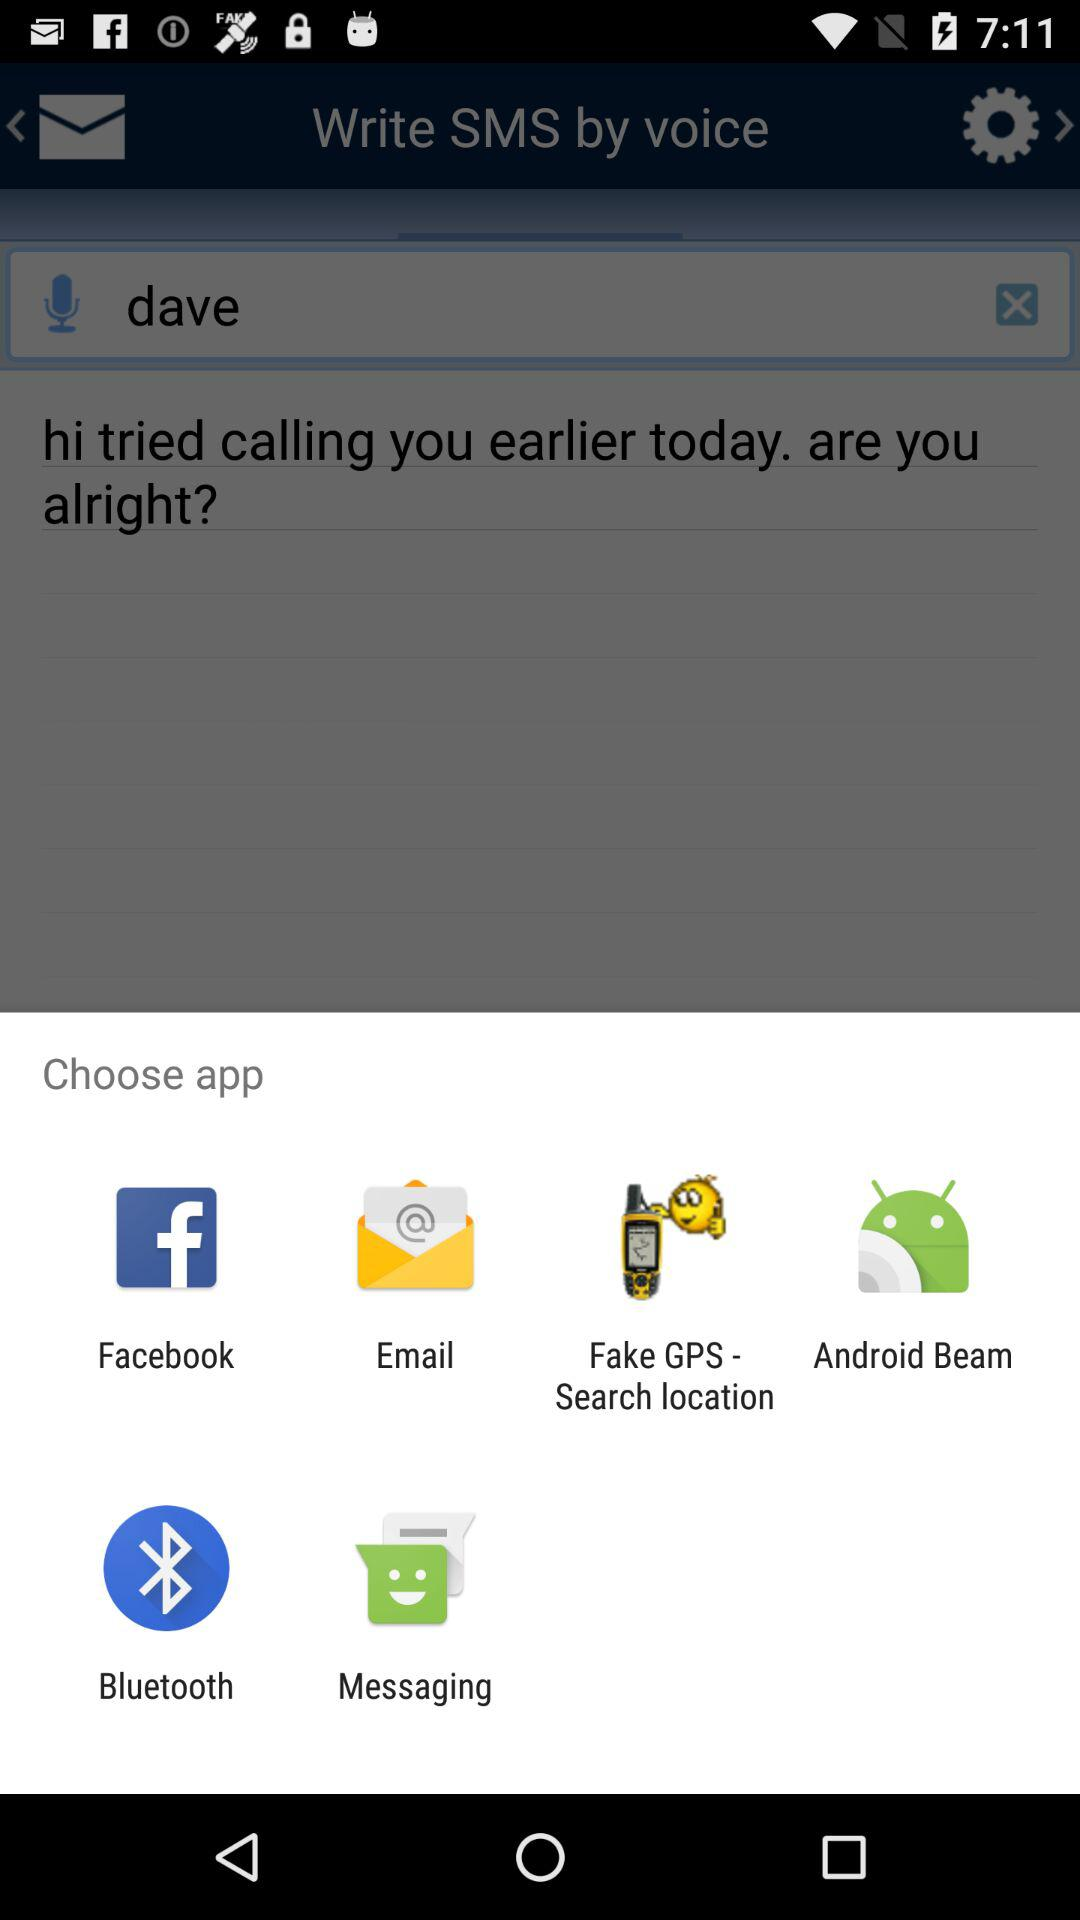What app options are given for choosing? The app options are Facebook, Email, Fake GPS - Search location, Android Beam, Bluetooth and Messaging. 